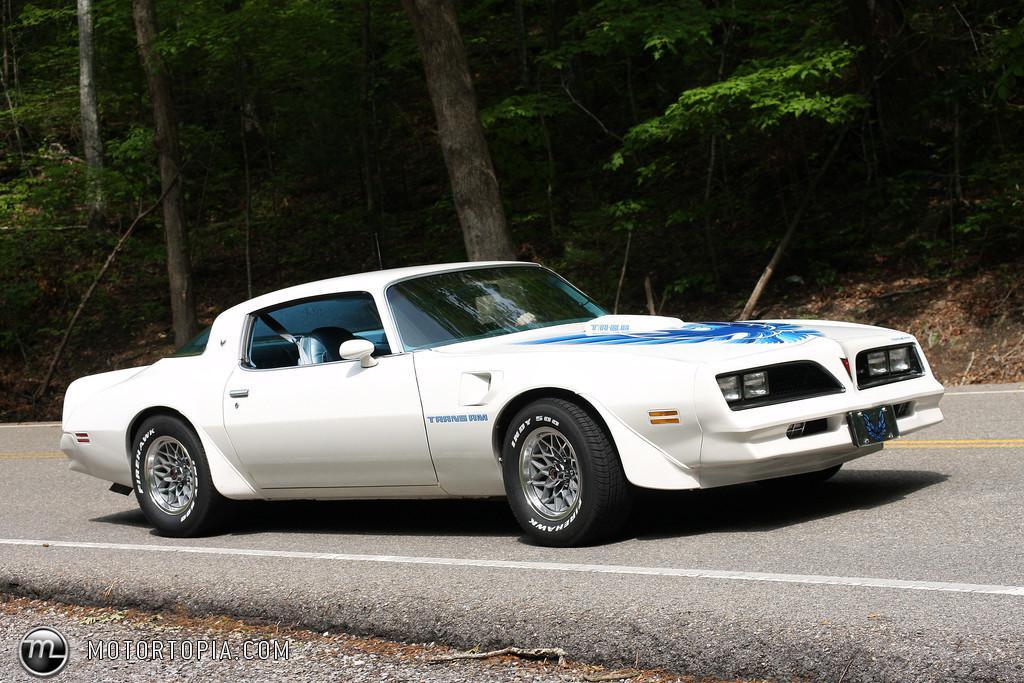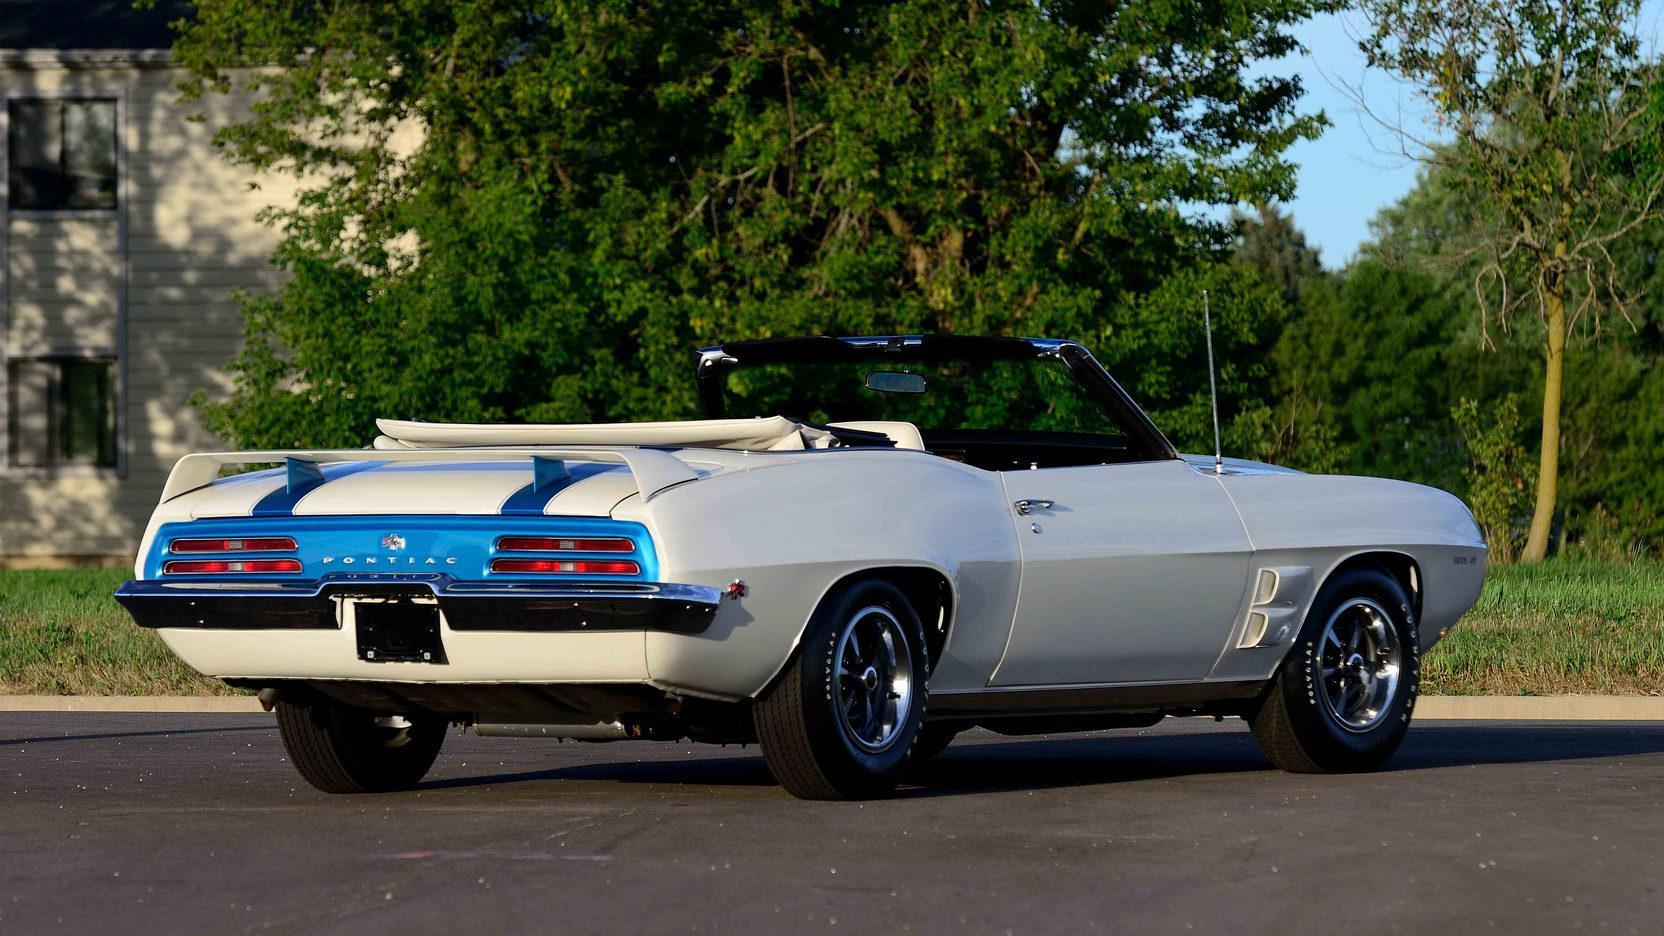The first image is the image on the left, the second image is the image on the right. Assess this claim about the two images: "Two cars are facing left.". Correct or not? Answer yes or no. No. 